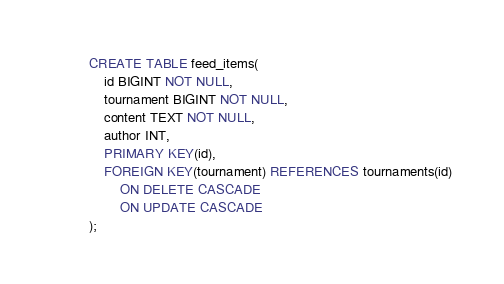Convert code to text. <code><loc_0><loc_0><loc_500><loc_500><_SQL_>CREATE TABLE feed_items(
	id BIGINT NOT NULL,
	tournament BIGINT NOT NULL,
	content TEXT NOT NULL,
	author INT,
	PRIMARY KEY(id),
	FOREIGN KEY(tournament) REFERENCES tournaments(id)
		ON DELETE CASCADE
		ON UPDATE CASCADE
);
</code> 